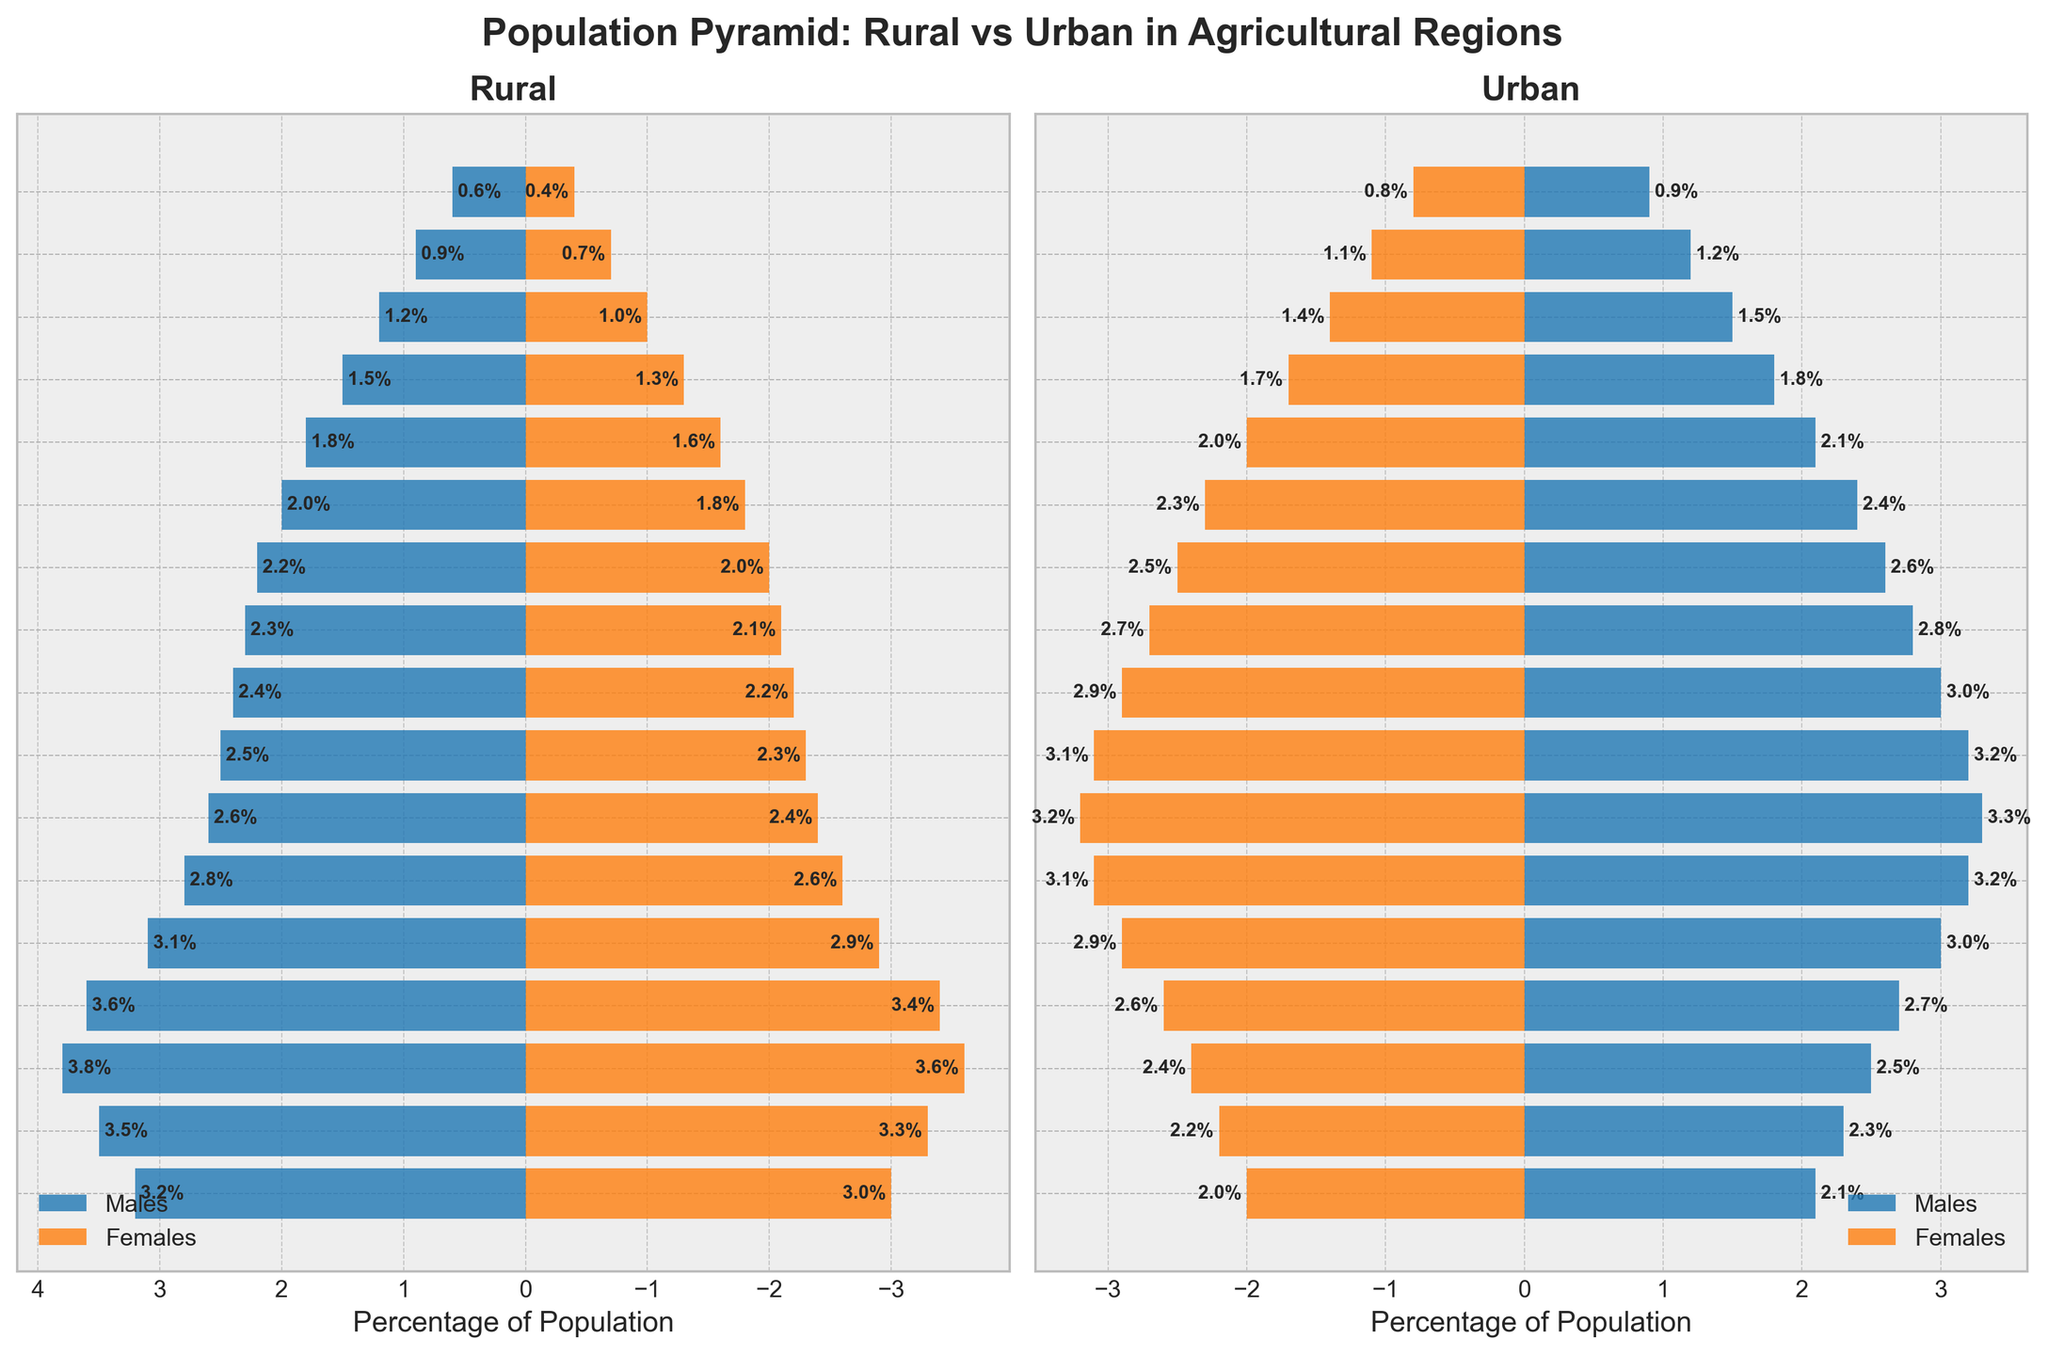Which age group has the highest percentage of rural males? By examining the rural male bars, the bar corresponding to the 10-14 age group is the longest.
Answer: 10-14 What is the percentage difference between urban males and urban females in the 25-29 age group? Urban males in the 25-29 age group have a percentage of 3.2, and urban females have a percentage of 3.1. The difference is 3.2 - 3.1 = 0.1.
Answer: 0.1 Which population, rural or urban, has a higher percentage of individuals in the 70-74 age group? By looking at both the rural and urban bars for the 70-74 age group, the urban bars are longer.
Answer: Urban In which age group is the percentage of rural females closest to the percentage of rural males? The 20-24 age group has rural males at 3.1% and rural females at 2.9%, the smallest difference between male and female percentages.
Answer: 20-24 How does the percentage of rural females in the 30-34 age group compare to urban females? Urban females in the 30-34 age group have a percentage of 3.2, while rural females have a percentage of 2.4. Urban females have a higher percentage.
Answer: Urban females are higher What is the total percentage of rural females in the 5-9 and 10-14 age groups? The percentage of rural females in the 5-9 age group is 3.3, and in the 10-14 age group is 3.6. The total is 3.3 + 3.6 = 6.9.
Answer: 6.9 Identify the age group where the rural population is relatively larger than the urban population. The rural population appears relatively larger than the urban population in age groups like 0-4, 5-9, 10-14 based on the bar lengths.
Answer: 0-14 (grouped response) Are there more urban males or rural males in the 50-54 age group? By comparing the bars for 50-54, urban males have a longer bar at 2.6% compared to rural males at 2.2%.
Answer: Urban males 